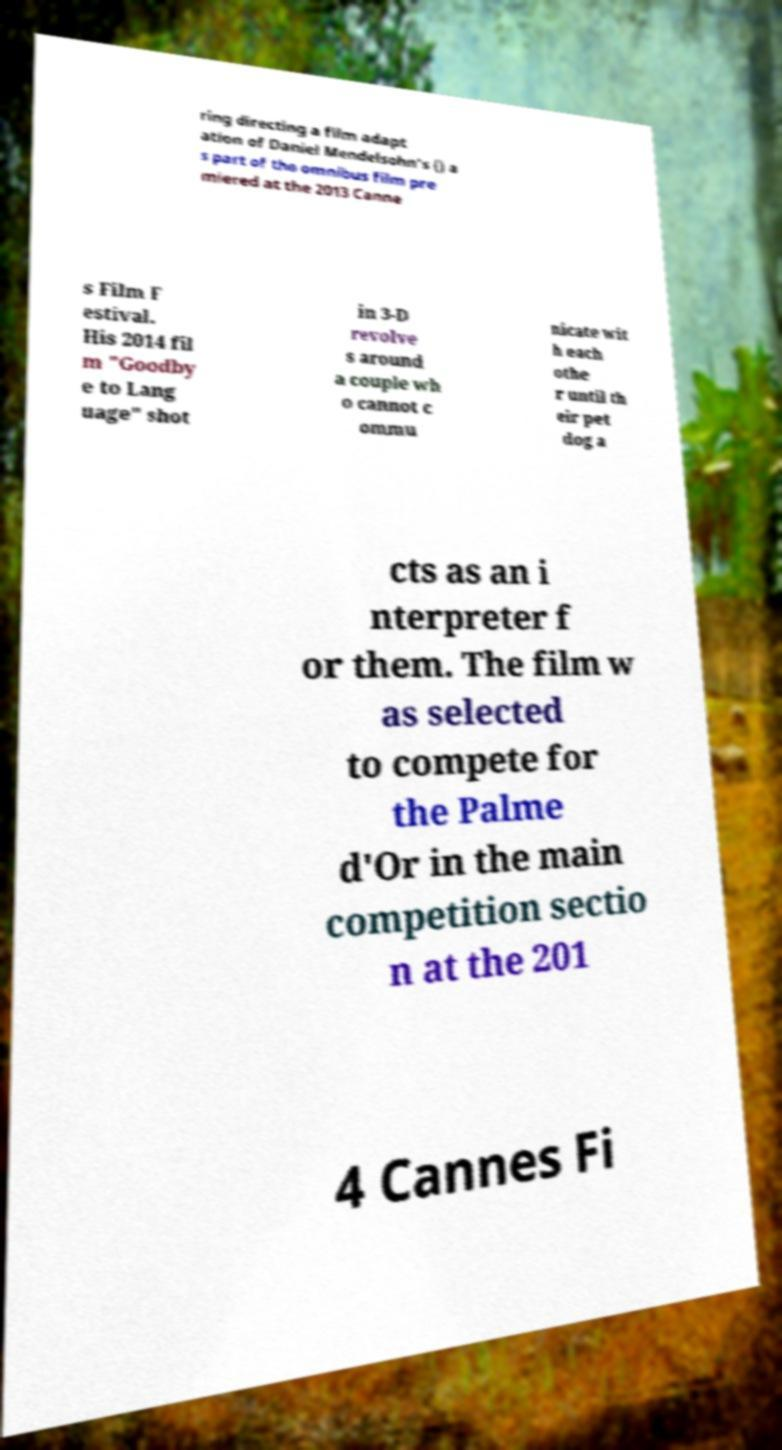Can you read and provide the text displayed in the image?This photo seems to have some interesting text. Can you extract and type it out for me? ring directing a film adapt ation of Daniel Mendelsohn's () a s part of the omnibus film pre miered at the 2013 Canne s Film F estival. His 2014 fil m "Goodby e to Lang uage" shot in 3-D revolve s around a couple wh o cannot c ommu nicate wit h each othe r until th eir pet dog a cts as an i nterpreter f or them. The film w as selected to compete for the Palme d'Or in the main competition sectio n at the 201 4 Cannes Fi 